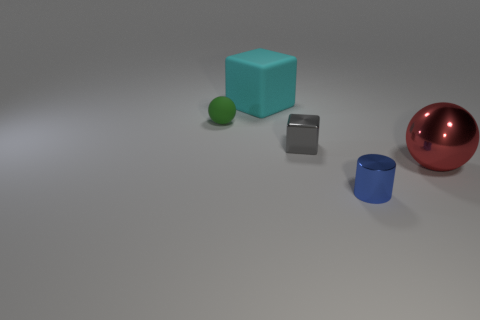Can you describe the lighting and shadows in the scene? Certainly! The scene is softly lit from above, casting gentle and diffused shadows beneath each object. The lighting does not appear to be very strong, but enough to create small yet noticeable shadows that help define the shapes of the objects. How might the direction of the light affect how the objects look? The direction of the light affects the appearance of the objects by influencing where the highlights and shadows fall. This can accentuate certain features or contours of the objects and gives a sense of depth and dimension to the composition. 